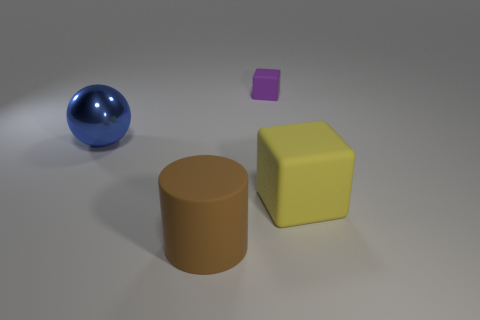Are there any other things that are made of the same material as the blue object?
Your response must be concise. No. There is a object that is to the left of the large brown cylinder that is in front of the blue object; are there any big yellow matte things in front of it?
Provide a short and direct response. Yes. Are there fewer large matte cubes than big rubber things?
Give a very brief answer. Yes. Does the rubber object that is behind the yellow rubber thing have the same shape as the large yellow matte thing?
Your answer should be compact. Yes. Are there any red shiny cylinders?
Give a very brief answer. No. There is a big rubber thing right of the matte thing left of the block that is behind the big yellow thing; what color is it?
Your response must be concise. Yellow. Are there an equal number of purple matte blocks that are on the left side of the big blue shiny object and brown cylinders that are on the right side of the big matte cylinder?
Provide a short and direct response. Yes. What is the shape of the brown matte thing that is the same size as the blue ball?
Ensure brevity in your answer.  Cylinder. Are there any other cylinders of the same color as the large matte cylinder?
Offer a very short reply. No. There is a matte object that is behind the big ball; what is its shape?
Give a very brief answer. Cube. 